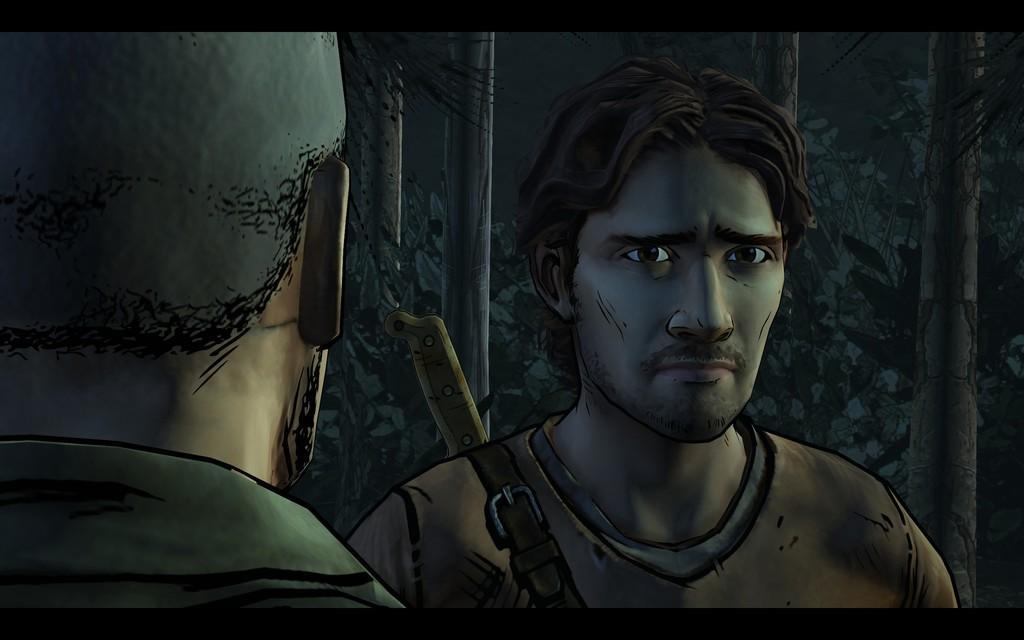Can you describe this image briefly? In this image we can see two men. In the background there are trees and plants. 